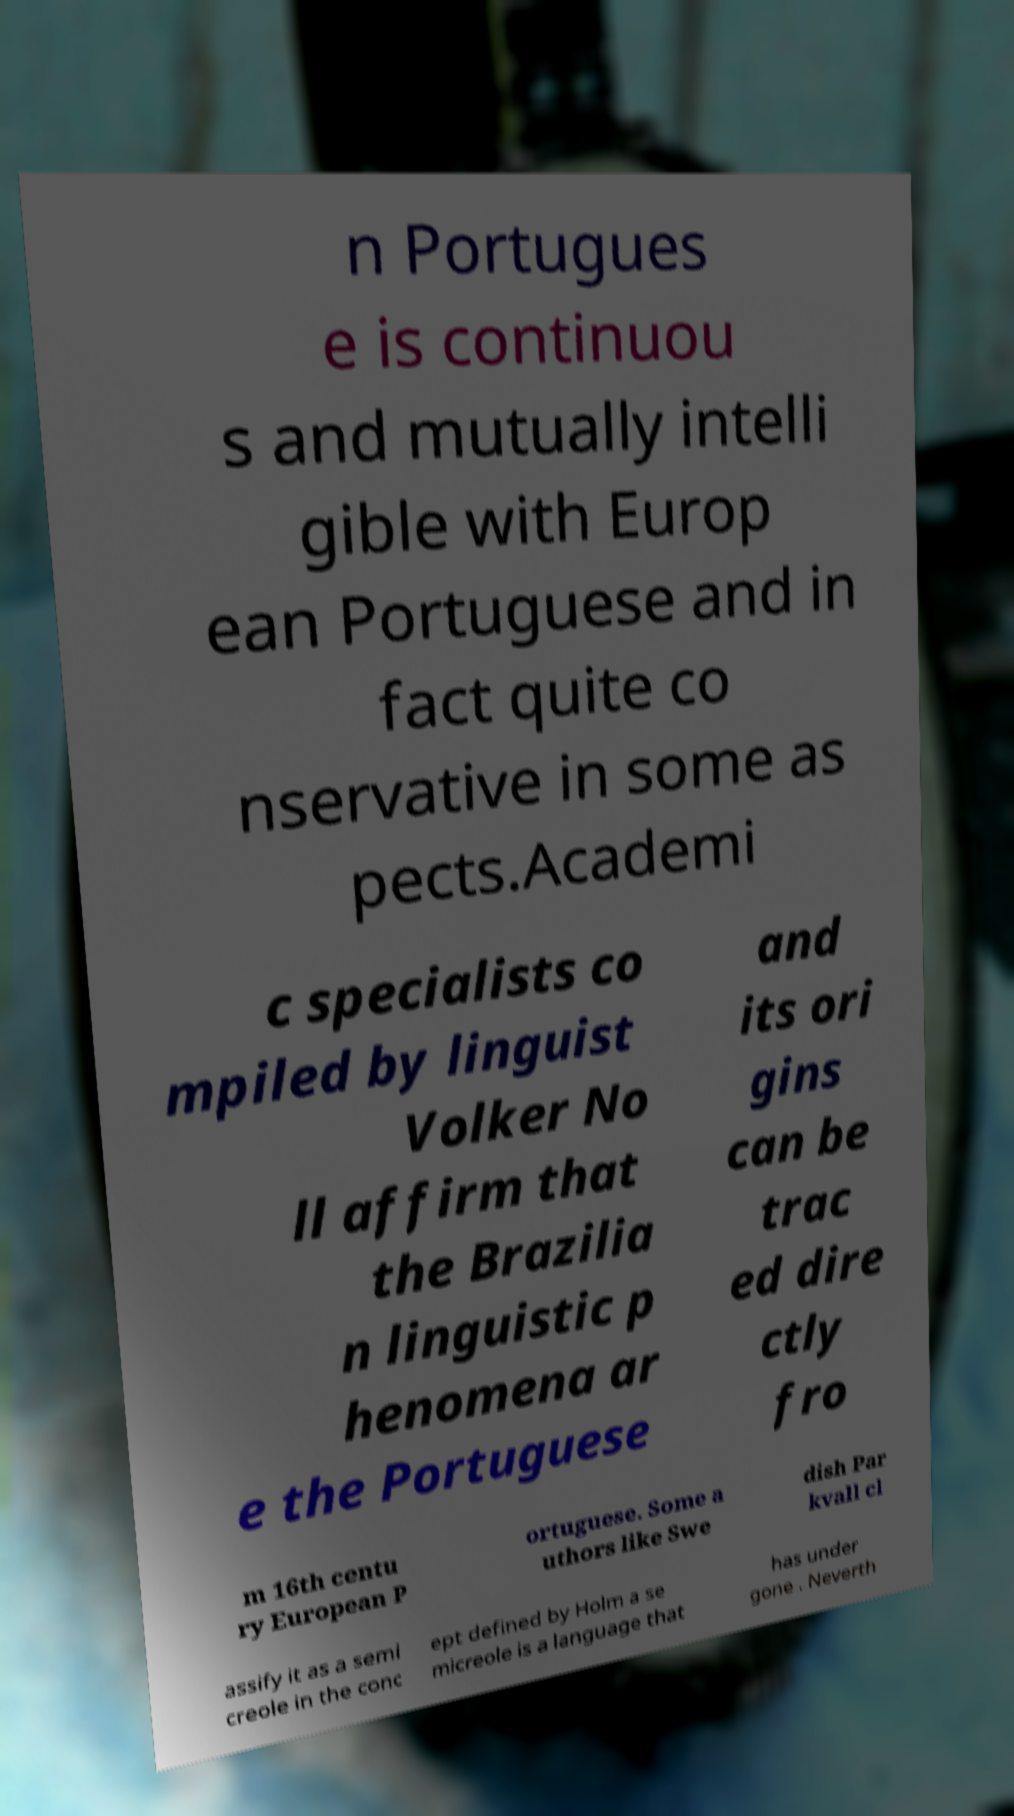What messages or text are displayed in this image? I need them in a readable, typed format. n Portugues e is continuou s and mutually intelli gible with Europ ean Portuguese and in fact quite co nservative in some as pects.Academi c specialists co mpiled by linguist Volker No ll affirm that the Brazilia n linguistic p henomena ar e the Portuguese and its ori gins can be trac ed dire ctly fro m 16th centu ry European P ortuguese. Some a uthors like Swe dish Par kvall cl assify it as a semi creole in the conc ept defined by Holm a se micreole is a language that has under gone . Neverth 